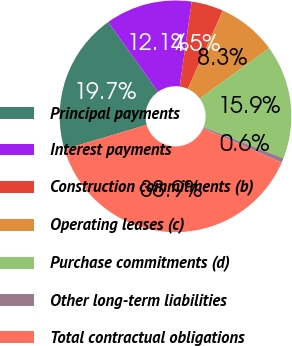Convert chart to OTSL. <chart><loc_0><loc_0><loc_500><loc_500><pie_chart><fcel>Principal payments<fcel>Interest payments<fcel>Construction commitments (b)<fcel>Operating leases (c)<fcel>Purchase commitments (d)<fcel>Other long-term liabilities<fcel>Total contractual obligations<nl><fcel>19.74%<fcel>12.1%<fcel>4.46%<fcel>8.28%<fcel>15.92%<fcel>0.64%<fcel>38.85%<nl></chart> 